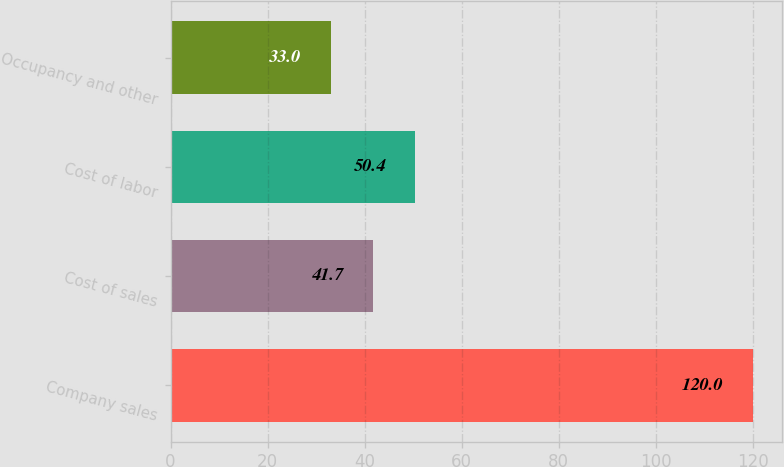<chart> <loc_0><loc_0><loc_500><loc_500><bar_chart><fcel>Company sales<fcel>Cost of sales<fcel>Cost of labor<fcel>Occupancy and other<nl><fcel>120<fcel>41.7<fcel>50.4<fcel>33<nl></chart> 